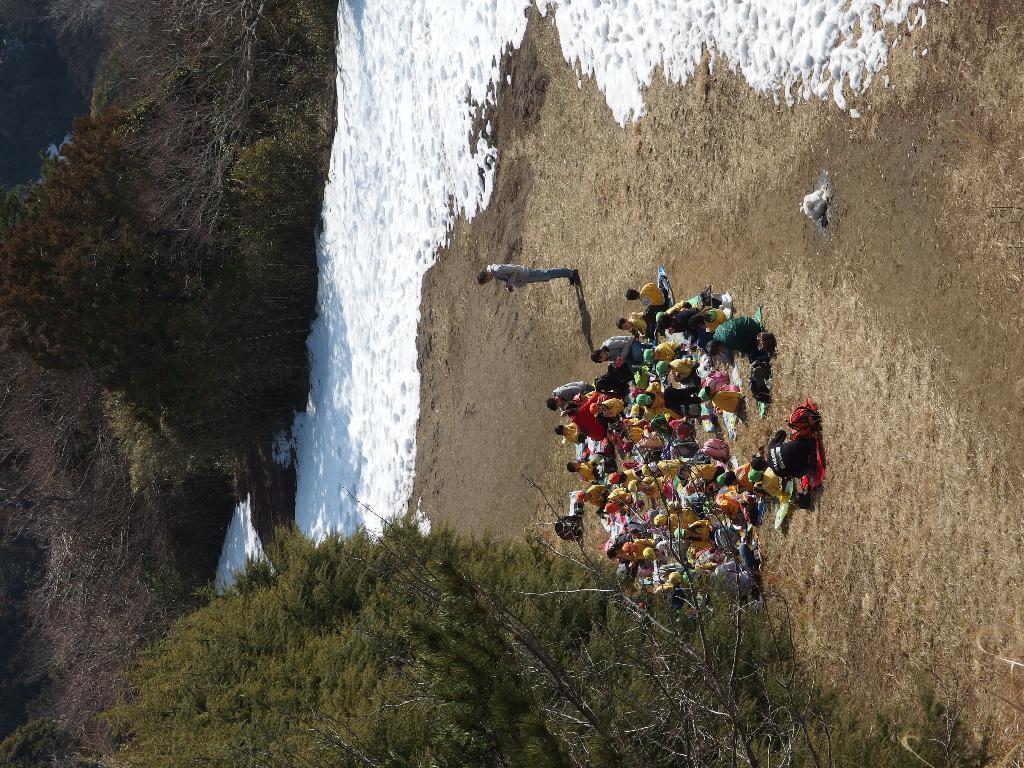Could you give a brief overview of what you see in this image? In this image we can see people sitting and there are trees. There is a man standing. In the background there is water. 